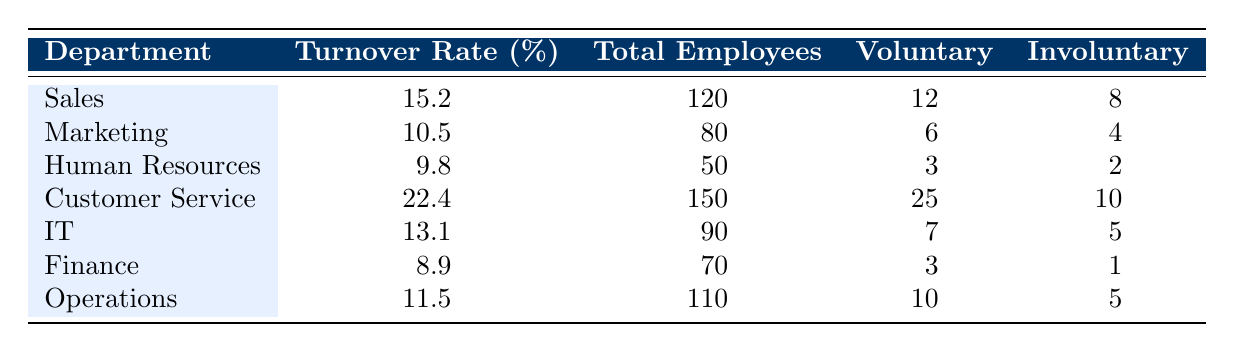What is the turnover rate for the Customer Service department? The table shows the turnover rate for the Customer Service department listed next to its name. The value provided is 22.4%.
Answer: 22.4% Which department has the highest total number of employees? By comparing the "Total Employees" column in the table, the Customer Service department has the highest total with 150 employees.
Answer: Customer Service What is the total voluntary turnover across all departments? To find the total voluntary turnover, sum the values in the "Voluntary" column: 12 + 6 + 3 + 25 + 7 + 3 + 10 = 66.
Answer: 66 Is the turnover rate for the IT department greater than that of the Finance department? Comparing the turnover rates, IT has 13.1% while Finance has 8.9%. Since 13.1% is greater than 8.9%, the answer is yes.
Answer: Yes What is the average turnover rate of all departments combined? To get the average turnover rate, we first sum the rates: 15.2 + 10.5 + 9.8 + 22.4 + 13.1 + 8.9 + 11.5 = 91.4. Next, divide by the number of departments (7): 91.4 / 7 = 13.03 (rounded to two decimal places is 13.0).
Answer: 13.0 Which department has the lowest voluntary turnover rate? Compare the "Voluntary" column; the Human Resources department has the lowest voluntary turnover with a count of 3 employees.
Answer: Human Resources What is the difference in involuntary turnover between Sales and IT departments? The involuntary turnover for Sales is 8 and for IT is 5. The difference is 8 - 5 = 3.
Answer: 3 Were there any departments with a turnover rate below 10%? The turnover rates for Human Resources (9.8%) and Finance (8.9%) are both below 10%, confirming that there are departments that meet this criteria.
Answer: Yes What percentage of employees in Customer Service left voluntarily? Divide the voluntary turnover (25) by the total employees (150) and multiply by 100: (25 / 150) * 100 = 16.67%.
Answer: 16.67% 